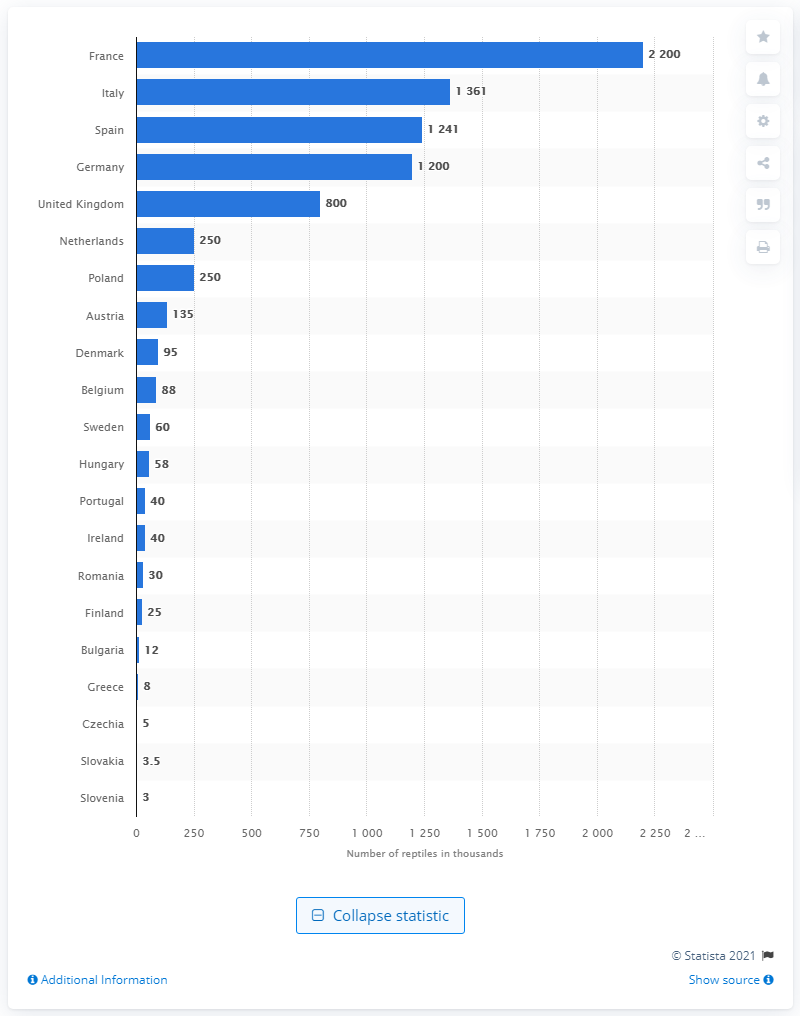Draw attention to some important aspects in this diagram. According to data from 2019, Spain ranked second in the world in terms of the number of reptiles kept as pets. 